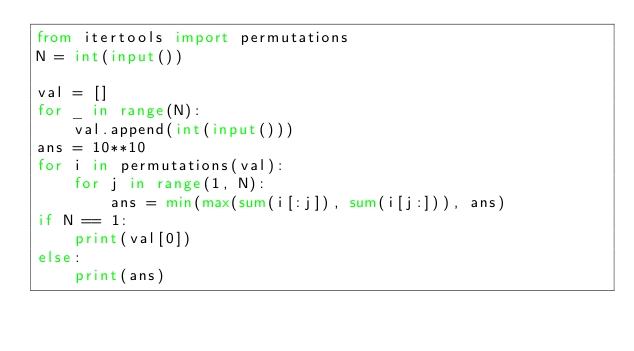<code> <loc_0><loc_0><loc_500><loc_500><_Python_>from itertools import permutations
N = int(input())

val = []
for _ in range(N):
    val.append(int(input()))
ans = 10**10
for i in permutations(val):
    for j in range(1, N):
        ans = min(max(sum(i[:j]), sum(i[j:])), ans)
if N == 1:
    print(val[0])
else:
    print(ans)
    

    
</code> 